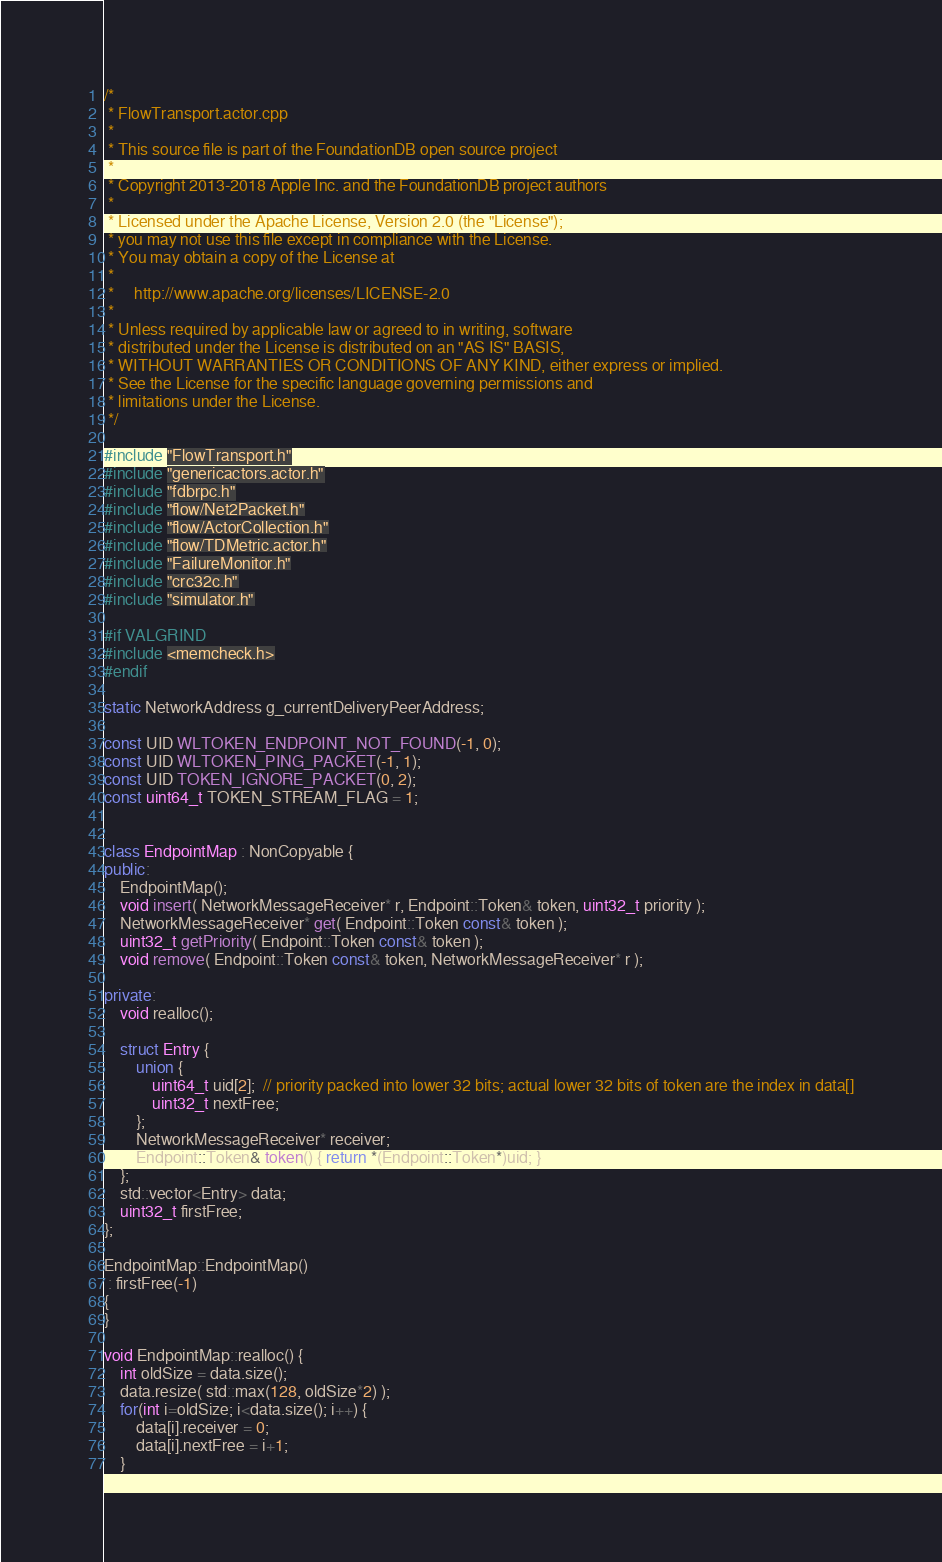Convert code to text. <code><loc_0><loc_0><loc_500><loc_500><_C++_>/*
 * FlowTransport.actor.cpp
 *
 * This source file is part of the FoundationDB open source project
 *
 * Copyright 2013-2018 Apple Inc. and the FoundationDB project authors
 *
 * Licensed under the Apache License, Version 2.0 (the "License");
 * you may not use this file except in compliance with the License.
 * You may obtain a copy of the License at
 *
 *     http://www.apache.org/licenses/LICENSE-2.0
 *
 * Unless required by applicable law or agreed to in writing, software
 * distributed under the License is distributed on an "AS IS" BASIS,
 * WITHOUT WARRANTIES OR CONDITIONS OF ANY KIND, either express or implied.
 * See the License for the specific language governing permissions and
 * limitations under the License.
 */

#include "FlowTransport.h"
#include "genericactors.actor.h"
#include "fdbrpc.h"
#include "flow/Net2Packet.h"
#include "flow/ActorCollection.h"
#include "flow/TDMetric.actor.h"
#include "FailureMonitor.h"
#include "crc32c.h"
#include "simulator.h"

#if VALGRIND
#include <memcheck.h>
#endif

static NetworkAddress g_currentDeliveryPeerAddress;

const UID WLTOKEN_ENDPOINT_NOT_FOUND(-1, 0);
const UID WLTOKEN_PING_PACKET(-1, 1);
const UID TOKEN_IGNORE_PACKET(0, 2);
const uint64_t TOKEN_STREAM_FLAG = 1;


class EndpointMap : NonCopyable {
public:
	EndpointMap();
	void insert( NetworkMessageReceiver* r, Endpoint::Token& token, uint32_t priority );
	NetworkMessageReceiver* get( Endpoint::Token const& token );
	uint32_t getPriority( Endpoint::Token const& token );
	void remove( Endpoint::Token const& token, NetworkMessageReceiver* r );

private:
	void realloc();

	struct Entry {
		union {
			uint64_t uid[2];  // priority packed into lower 32 bits; actual lower 32 bits of token are the index in data[]
			uint32_t nextFree;
		};
		NetworkMessageReceiver* receiver;
		Endpoint::Token& token() { return *(Endpoint::Token*)uid; }
	};
	std::vector<Entry> data;
	uint32_t firstFree;
};

EndpointMap::EndpointMap() 
 : firstFree(-1) 
{
}

void EndpointMap::realloc() {
	int oldSize = data.size();
	data.resize( std::max(128, oldSize*2) );
	for(int i=oldSize; i<data.size(); i++) {
		data[i].receiver = 0;
		data[i].nextFree = i+1;
	}</code> 